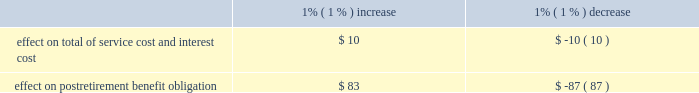United parcel service , inc .
And subsidiaries notes to consolidated financial statements 2014 ( continued ) a discount rate is used to determine the present value of our future benefit obligations .
In 2008 and prior years , the discount rate for u.s .
Plans was determined by matching the expected cash flows to a yield curve based on long-term , high quality fixed income debt instruments available as of the measurement date .
In 2008 , we reduced the population of bonds from which the yield curve was developed to better reflect bonds we would more likely consider to settle our obligations .
In 2009 , we further enhanced this process for plans in the u.s .
By using a bond matching approach to select specific bonds that would satisfy our projected benefit payments .
We believe the bond matching approach more closely reflects the process we would employ to settle our pension and postretirement benefit obligations .
These modifications had an impact of increasing the pension benefits and postretirement medical benefits discount rate on average 31 and 51 basis points for 2009 and 25 and 17 basis points for 2008 .
For 2009 , each basis point increase in the discount rate decreases the projected benefit obligation by approximately $ 25 million and $ 3 million for pension and postretirement medical benefits , respectively .
For our international plans , the discount rate is selected based on high quality fixed income indices available in the country in which the plan is domiciled .
These assumptions are updated annually .
An assumption for expected return on plan assets is used to determine a component of net periodic benefit cost for the fiscal year .
This assumption for our u.s .
Plans was developed using a long-term projection of returns for each asset class , and taking into consideration our target asset allocation .
The expected return for each asset class is a function of passive , long-term capital market assumptions and excess returns generated from active management .
The capital market assumptions used are provided by independent investment advisors , while excess return assumptions are supported by historical performance , fund mandates and investment expectations .
In addition , we compare the expected return on asset assumption with the average historical rate of return these plans have been able to generate .
For the ups retirement plan , we use a market-related valuation method for recognizing investment gains or losses .
Investment gains or losses are the difference between the expected and actual return based on the market- related value of assets .
This method recognizes investment gains or losses over a five year period from the year in which they occur , which reduces year-to-year volatility in pension expense .
Our expense in future periods will be impacted as gains or losses are recognized in the market-related value of assets .
For plans outside the u.s. , consideration is given to local market expectations of long-term returns .
Strategic asset allocations are determined by country , based on the nature of liabilities and considering the demographic composition of the plan participants .
Health care cost trends are used to project future postretirement benefits payable from our plans .
For year-end 2009 u.s .
Plan obligations , future postretirement medical benefit costs were forecasted assuming an initial annual increase of 8.0% ( 8.0 % ) , decreasing to 5.0% ( 5.0 % ) by the year 2016 and with consistent annual increases at those ultimate levels thereafter .
Assumed health care cost trends have a significant effect on the amounts reported for the u.s .
Postretirement medical plans .
A one-percent change in assumed health care cost trend rates would have the following effects ( in millions ) : .

What is the current total of service cost and interest cost? 
Computations: (10 / 1%)
Answer: 1000.0. 